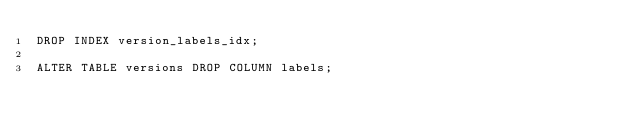<code> <loc_0><loc_0><loc_500><loc_500><_SQL_>DROP INDEX version_labels_idx;

ALTER TABLE versions DROP COLUMN labels;
</code> 